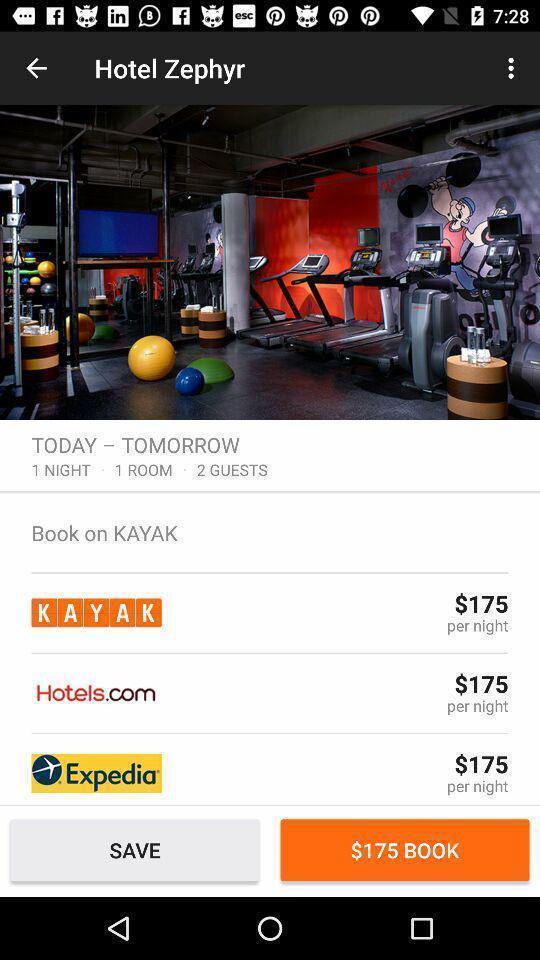What can you discern from this picture? Page with list of hotels for booking. 